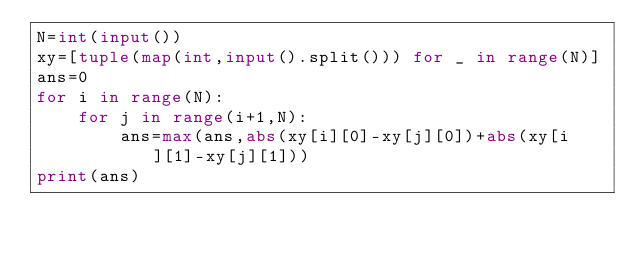Convert code to text. <code><loc_0><loc_0><loc_500><loc_500><_Python_>N=int(input())
xy=[tuple(map(int,input().split())) for _ in range(N)]
ans=0
for i in range(N):
    for j in range(i+1,N):
        ans=max(ans,abs(xy[i][0]-xy[j][0])+abs(xy[i][1]-xy[j][1]))
print(ans)</code> 